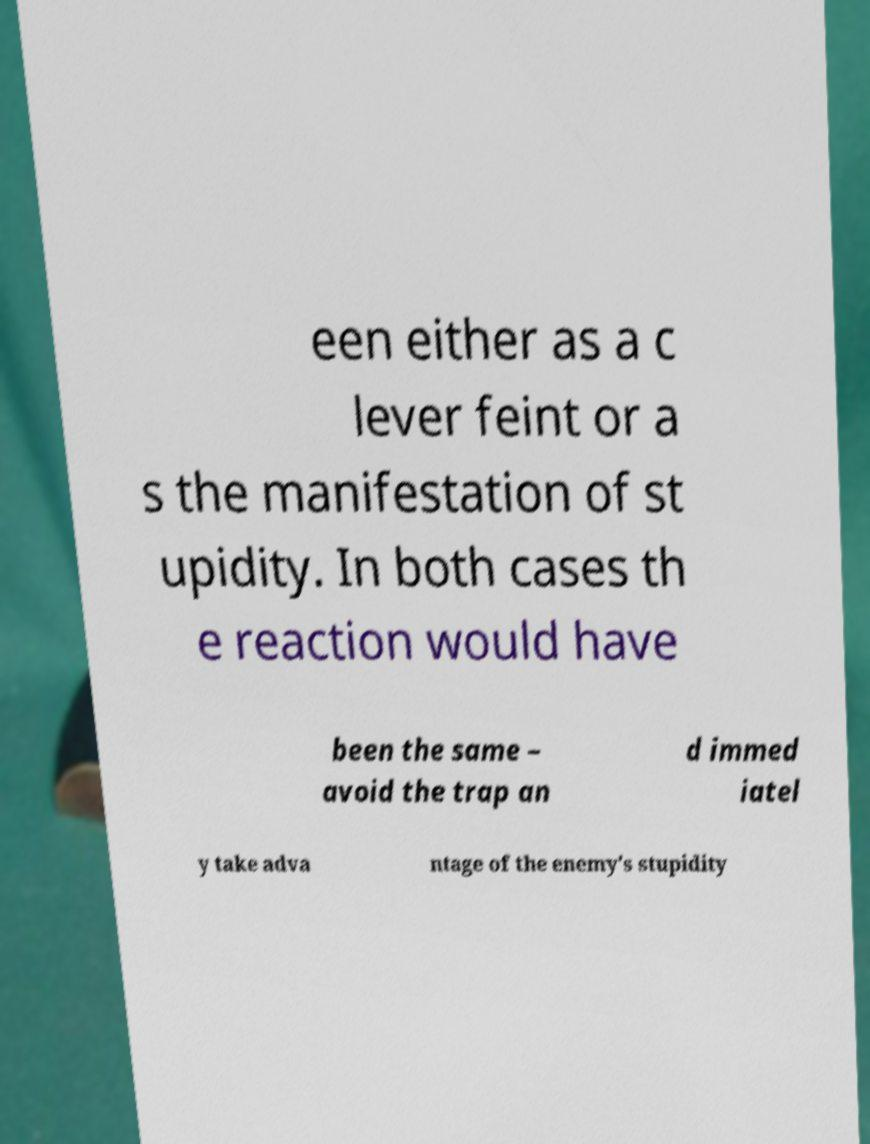Could you extract and type out the text from this image? een either as a c lever feint or a s the manifestation of st upidity. In both cases th e reaction would have been the same – avoid the trap an d immed iatel y take adva ntage of the enemy's stupidity 